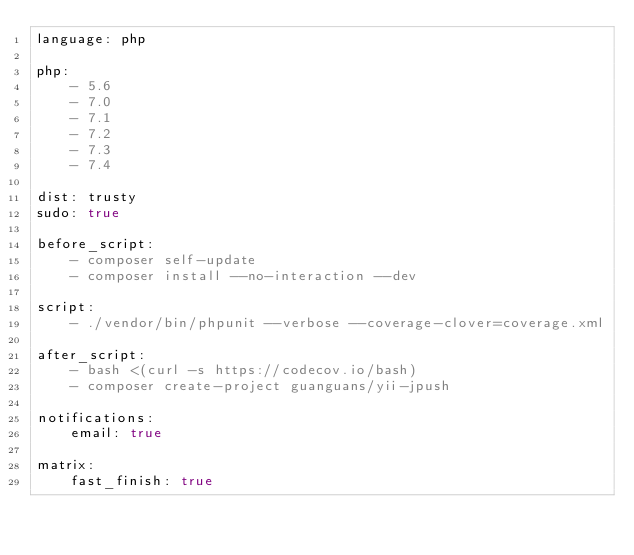<code> <loc_0><loc_0><loc_500><loc_500><_YAML_>language: php

php:
    - 5.6
    - 7.0
    - 7.1
    - 7.2
    - 7.3
    - 7.4

dist: trusty
sudo: true

before_script:
    - composer self-update
    - composer install --no-interaction --dev

script:
    - ./vendor/bin/phpunit --verbose --coverage-clover=coverage.xml

after_script:
    - bash <(curl -s https://codecov.io/bash)
    - composer create-project guanguans/yii-jpush

notifications:
    email: true

matrix:
    fast_finish: true</code> 